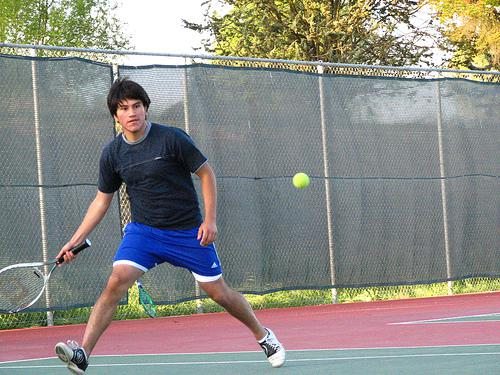Question: where was the photo taken?
Choices:
A. At the beach.
B. At the baseball game.
C. In the park.
D. On a tennis court.
Answer with the letter. Answer: D Question: what is the boy doing?
Choices:
A. Skiing.
B. Playing tennis.
C. Swimming.
D. Skateboarding.
Answer with the letter. Answer: B Question: what is surrounding the tennis court?
Choices:
A. Chairs.
B. Spectators.
C. Walls.
D. A fence.
Answer with the letter. Answer: D Question: what is in the boy's right hand?
Choices:
A. A helmet.
B. A hockey stick.
C. A glove.
D. A tennis racket.
Answer with the letter. Answer: D 